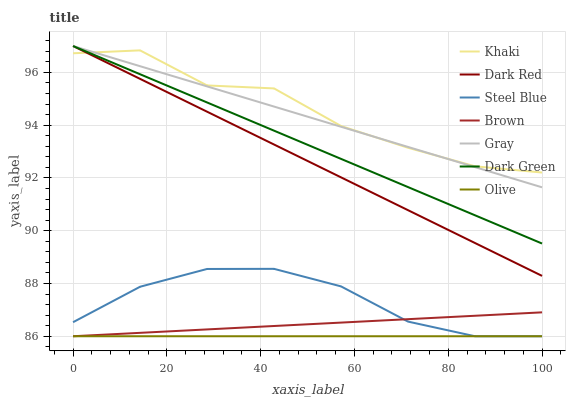Does Olive have the minimum area under the curve?
Answer yes or no. Yes. Does Khaki have the maximum area under the curve?
Answer yes or no. Yes. Does Brown have the minimum area under the curve?
Answer yes or no. No. Does Brown have the maximum area under the curve?
Answer yes or no. No. Is Olive the smoothest?
Answer yes or no. Yes. Is Khaki the roughest?
Answer yes or no. Yes. Is Brown the smoothest?
Answer yes or no. No. Is Brown the roughest?
Answer yes or no. No. Does Khaki have the lowest value?
Answer yes or no. No. Does Dark Green have the highest value?
Answer yes or no. Yes. Does Khaki have the highest value?
Answer yes or no. No. Is Olive less than Dark Green?
Answer yes or no. Yes. Is Dark Red greater than Steel Blue?
Answer yes or no. Yes. Does Olive intersect Brown?
Answer yes or no. Yes. Is Olive less than Brown?
Answer yes or no. No. Is Olive greater than Brown?
Answer yes or no. No. Does Olive intersect Dark Green?
Answer yes or no. No. 